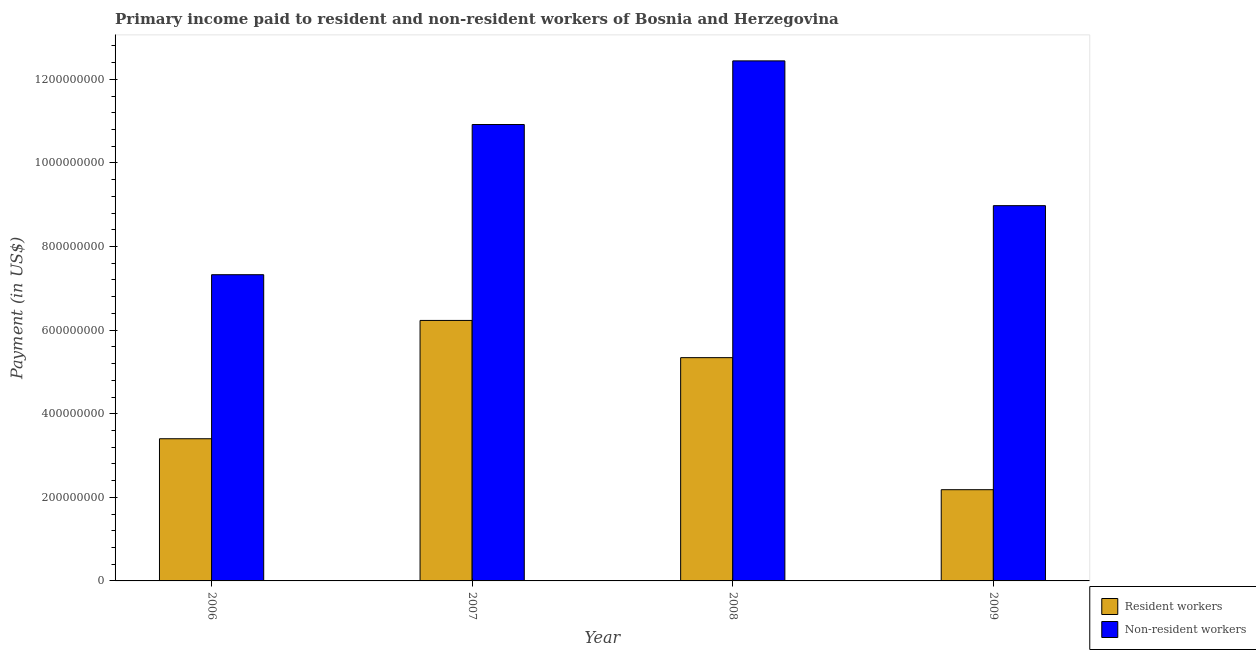How many different coloured bars are there?
Give a very brief answer. 2. How many bars are there on the 4th tick from the left?
Your answer should be compact. 2. In how many cases, is the number of bars for a given year not equal to the number of legend labels?
Your answer should be compact. 0. What is the payment made to non-resident workers in 2007?
Ensure brevity in your answer.  1.09e+09. Across all years, what is the maximum payment made to non-resident workers?
Your answer should be very brief. 1.24e+09. Across all years, what is the minimum payment made to non-resident workers?
Your answer should be compact. 7.33e+08. In which year was the payment made to non-resident workers minimum?
Your response must be concise. 2006. What is the total payment made to resident workers in the graph?
Ensure brevity in your answer.  1.72e+09. What is the difference between the payment made to non-resident workers in 2006 and that in 2008?
Offer a very short reply. -5.12e+08. What is the difference between the payment made to non-resident workers in 2006 and the payment made to resident workers in 2008?
Provide a succinct answer. -5.12e+08. What is the average payment made to resident workers per year?
Keep it short and to the point. 4.29e+08. In the year 2008, what is the difference between the payment made to resident workers and payment made to non-resident workers?
Provide a succinct answer. 0. What is the ratio of the payment made to non-resident workers in 2008 to that in 2009?
Your answer should be very brief. 1.39. Is the difference between the payment made to non-resident workers in 2006 and 2007 greater than the difference between the payment made to resident workers in 2006 and 2007?
Provide a succinct answer. No. What is the difference between the highest and the second highest payment made to resident workers?
Keep it short and to the point. 8.91e+07. What is the difference between the highest and the lowest payment made to resident workers?
Your answer should be compact. 4.05e+08. In how many years, is the payment made to resident workers greater than the average payment made to resident workers taken over all years?
Provide a succinct answer. 2. What does the 1st bar from the left in 2008 represents?
Your answer should be very brief. Resident workers. What does the 1st bar from the right in 2007 represents?
Provide a succinct answer. Non-resident workers. Are all the bars in the graph horizontal?
Provide a succinct answer. No. What is the difference between two consecutive major ticks on the Y-axis?
Your answer should be compact. 2.00e+08. Are the values on the major ticks of Y-axis written in scientific E-notation?
Your response must be concise. No. Does the graph contain any zero values?
Provide a succinct answer. No. What is the title of the graph?
Provide a short and direct response. Primary income paid to resident and non-resident workers of Bosnia and Herzegovina. Does "Exports" appear as one of the legend labels in the graph?
Ensure brevity in your answer.  No. What is the label or title of the Y-axis?
Keep it short and to the point. Payment (in US$). What is the Payment (in US$) in Resident workers in 2006?
Offer a very short reply. 3.40e+08. What is the Payment (in US$) of Non-resident workers in 2006?
Your response must be concise. 7.33e+08. What is the Payment (in US$) in Resident workers in 2007?
Make the answer very short. 6.23e+08. What is the Payment (in US$) of Non-resident workers in 2007?
Provide a short and direct response. 1.09e+09. What is the Payment (in US$) in Resident workers in 2008?
Offer a terse response. 5.34e+08. What is the Payment (in US$) of Non-resident workers in 2008?
Your answer should be compact. 1.24e+09. What is the Payment (in US$) of Resident workers in 2009?
Your answer should be very brief. 2.18e+08. What is the Payment (in US$) of Non-resident workers in 2009?
Ensure brevity in your answer.  8.98e+08. Across all years, what is the maximum Payment (in US$) of Resident workers?
Offer a terse response. 6.23e+08. Across all years, what is the maximum Payment (in US$) in Non-resident workers?
Provide a short and direct response. 1.24e+09. Across all years, what is the minimum Payment (in US$) in Resident workers?
Give a very brief answer. 2.18e+08. Across all years, what is the minimum Payment (in US$) in Non-resident workers?
Provide a short and direct response. 7.33e+08. What is the total Payment (in US$) of Resident workers in the graph?
Your answer should be compact. 1.72e+09. What is the total Payment (in US$) in Non-resident workers in the graph?
Your answer should be very brief. 3.97e+09. What is the difference between the Payment (in US$) in Resident workers in 2006 and that in 2007?
Keep it short and to the point. -2.83e+08. What is the difference between the Payment (in US$) of Non-resident workers in 2006 and that in 2007?
Your answer should be compact. -3.59e+08. What is the difference between the Payment (in US$) in Resident workers in 2006 and that in 2008?
Your answer should be compact. -1.94e+08. What is the difference between the Payment (in US$) of Non-resident workers in 2006 and that in 2008?
Make the answer very short. -5.12e+08. What is the difference between the Payment (in US$) of Resident workers in 2006 and that in 2009?
Ensure brevity in your answer.  1.22e+08. What is the difference between the Payment (in US$) in Non-resident workers in 2006 and that in 2009?
Your answer should be compact. -1.65e+08. What is the difference between the Payment (in US$) in Resident workers in 2007 and that in 2008?
Offer a terse response. 8.91e+07. What is the difference between the Payment (in US$) in Non-resident workers in 2007 and that in 2008?
Ensure brevity in your answer.  -1.52e+08. What is the difference between the Payment (in US$) in Resident workers in 2007 and that in 2009?
Ensure brevity in your answer.  4.05e+08. What is the difference between the Payment (in US$) of Non-resident workers in 2007 and that in 2009?
Your answer should be compact. 1.94e+08. What is the difference between the Payment (in US$) in Resident workers in 2008 and that in 2009?
Make the answer very short. 3.16e+08. What is the difference between the Payment (in US$) of Non-resident workers in 2008 and that in 2009?
Provide a short and direct response. 3.46e+08. What is the difference between the Payment (in US$) in Resident workers in 2006 and the Payment (in US$) in Non-resident workers in 2007?
Provide a short and direct response. -7.52e+08. What is the difference between the Payment (in US$) of Resident workers in 2006 and the Payment (in US$) of Non-resident workers in 2008?
Offer a very short reply. -9.04e+08. What is the difference between the Payment (in US$) in Resident workers in 2006 and the Payment (in US$) in Non-resident workers in 2009?
Your response must be concise. -5.58e+08. What is the difference between the Payment (in US$) in Resident workers in 2007 and the Payment (in US$) in Non-resident workers in 2008?
Provide a succinct answer. -6.21e+08. What is the difference between the Payment (in US$) of Resident workers in 2007 and the Payment (in US$) of Non-resident workers in 2009?
Keep it short and to the point. -2.75e+08. What is the difference between the Payment (in US$) of Resident workers in 2008 and the Payment (in US$) of Non-resident workers in 2009?
Ensure brevity in your answer.  -3.64e+08. What is the average Payment (in US$) in Resident workers per year?
Keep it short and to the point. 4.29e+08. What is the average Payment (in US$) in Non-resident workers per year?
Your response must be concise. 9.92e+08. In the year 2006, what is the difference between the Payment (in US$) of Resident workers and Payment (in US$) of Non-resident workers?
Provide a succinct answer. -3.92e+08. In the year 2007, what is the difference between the Payment (in US$) of Resident workers and Payment (in US$) of Non-resident workers?
Your answer should be compact. -4.69e+08. In the year 2008, what is the difference between the Payment (in US$) in Resident workers and Payment (in US$) in Non-resident workers?
Your answer should be compact. -7.10e+08. In the year 2009, what is the difference between the Payment (in US$) of Resident workers and Payment (in US$) of Non-resident workers?
Keep it short and to the point. -6.80e+08. What is the ratio of the Payment (in US$) of Resident workers in 2006 to that in 2007?
Give a very brief answer. 0.55. What is the ratio of the Payment (in US$) of Non-resident workers in 2006 to that in 2007?
Keep it short and to the point. 0.67. What is the ratio of the Payment (in US$) in Resident workers in 2006 to that in 2008?
Provide a short and direct response. 0.64. What is the ratio of the Payment (in US$) in Non-resident workers in 2006 to that in 2008?
Give a very brief answer. 0.59. What is the ratio of the Payment (in US$) in Resident workers in 2006 to that in 2009?
Ensure brevity in your answer.  1.56. What is the ratio of the Payment (in US$) in Non-resident workers in 2006 to that in 2009?
Offer a very short reply. 0.82. What is the ratio of the Payment (in US$) in Resident workers in 2007 to that in 2008?
Offer a very short reply. 1.17. What is the ratio of the Payment (in US$) of Non-resident workers in 2007 to that in 2008?
Offer a very short reply. 0.88. What is the ratio of the Payment (in US$) in Resident workers in 2007 to that in 2009?
Make the answer very short. 2.86. What is the ratio of the Payment (in US$) of Non-resident workers in 2007 to that in 2009?
Provide a short and direct response. 1.22. What is the ratio of the Payment (in US$) of Resident workers in 2008 to that in 2009?
Your answer should be compact. 2.45. What is the ratio of the Payment (in US$) of Non-resident workers in 2008 to that in 2009?
Keep it short and to the point. 1.39. What is the difference between the highest and the second highest Payment (in US$) in Resident workers?
Make the answer very short. 8.91e+07. What is the difference between the highest and the second highest Payment (in US$) in Non-resident workers?
Provide a succinct answer. 1.52e+08. What is the difference between the highest and the lowest Payment (in US$) in Resident workers?
Your answer should be compact. 4.05e+08. What is the difference between the highest and the lowest Payment (in US$) of Non-resident workers?
Your answer should be very brief. 5.12e+08. 